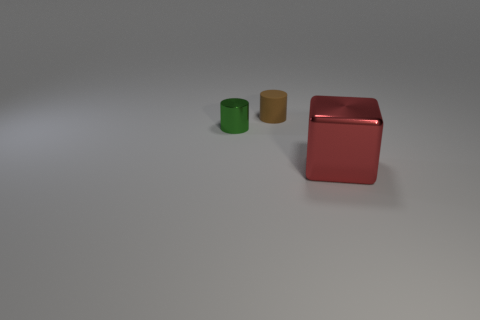Do the red metallic object and the metal thing behind the large block have the same size? Based on visual assessment, the red metallic object and the metal thing behind the large block do not appear to have the same size. They seem to have significant differences in their dimensions, with the red metallic object being substantially larger. 